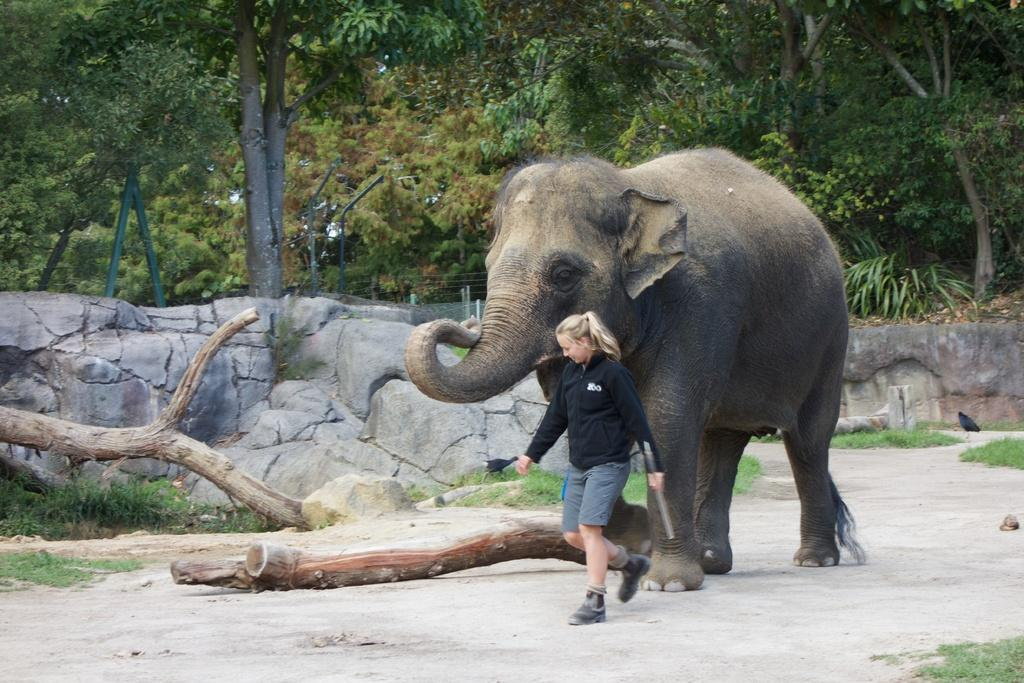What animal can be seen in the picture? There is an elephant in the picture. What part of a tree is visible in the picture? There is a trunk of a tree in the picture. What is the woman in the picture doing? There is a woman walking in front of the elephant. What can be seen in the background of the picture? There are trees visible in the background of the picture. What type of lumber is being used to build the air in the picture? There is no mention of lumber or air in the picture; it features an elephant, a tree trunk, a woman walking, and trees in the background. 